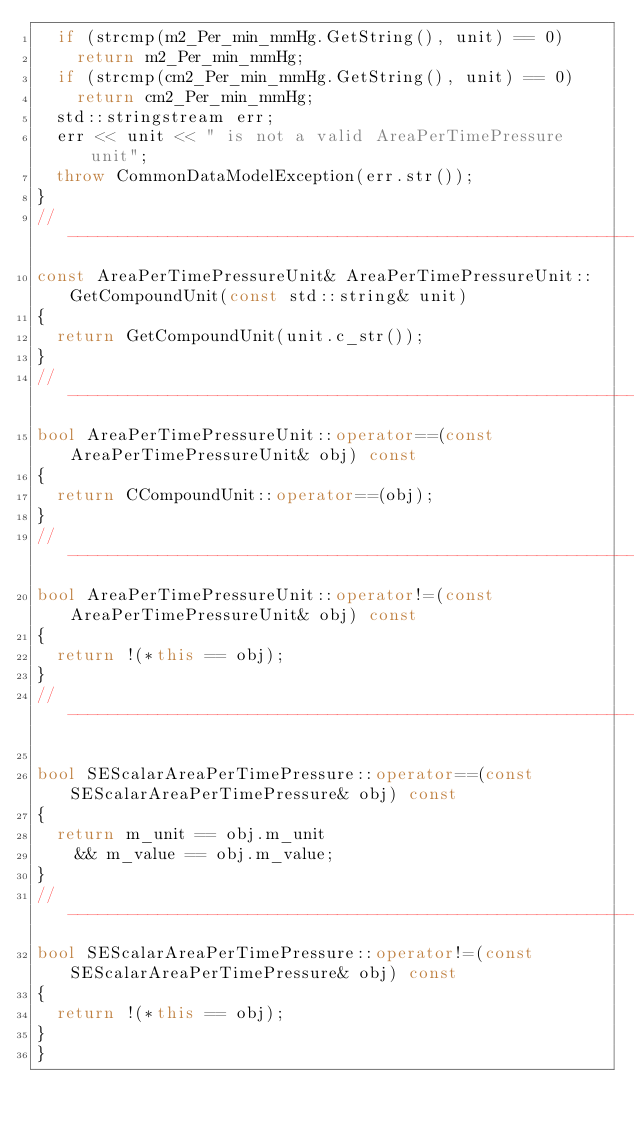<code> <loc_0><loc_0><loc_500><loc_500><_C++_>  if (strcmp(m2_Per_min_mmHg.GetString(), unit) == 0)
    return m2_Per_min_mmHg;
  if (strcmp(cm2_Per_min_mmHg.GetString(), unit) == 0)
    return cm2_Per_min_mmHg;
  std::stringstream err;
  err << unit << " is not a valid AreaPerTimePressure unit";
  throw CommonDataModelException(err.str());
}
//-----------------------------------------------------------------------------
const AreaPerTimePressureUnit& AreaPerTimePressureUnit::GetCompoundUnit(const std::string& unit)
{
  return GetCompoundUnit(unit.c_str());
}
//-----------------------------------------------------------------------------
bool AreaPerTimePressureUnit::operator==(const AreaPerTimePressureUnit& obj) const
{
  return CCompoundUnit::operator==(obj);
}
//-------------------------------------------------------------------------------
bool AreaPerTimePressureUnit::operator!=(const AreaPerTimePressureUnit& obj) const
{
  return !(*this == obj);
}
//-------------------------------------------------------------------------------

bool SEScalarAreaPerTimePressure::operator==(const SEScalarAreaPerTimePressure& obj) const
{
  return m_unit == obj.m_unit
    && m_value == obj.m_value;
}
//-------------------------------------------------------------------------------
bool SEScalarAreaPerTimePressure::operator!=(const SEScalarAreaPerTimePressure& obj) const
{
  return !(*this == obj);
}
}</code> 